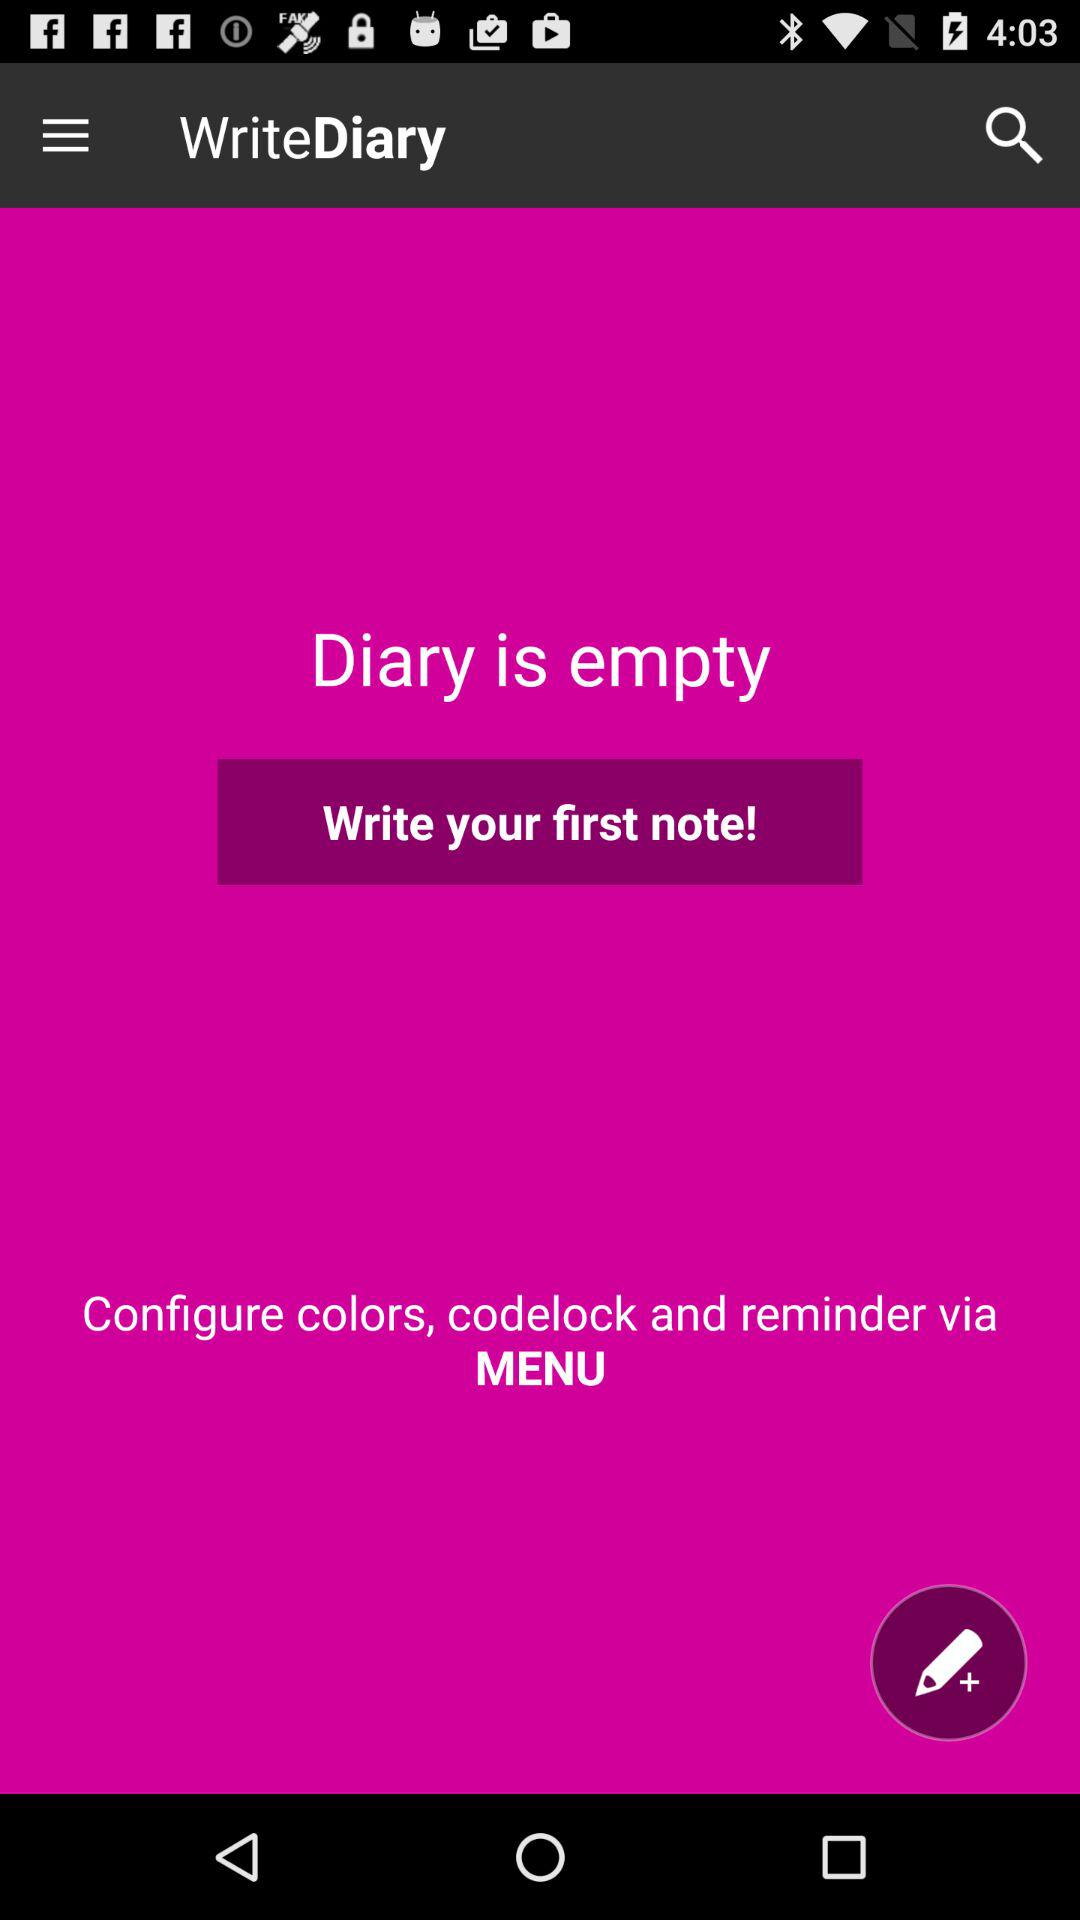What is the application name? The application name is "WriteDiary". 